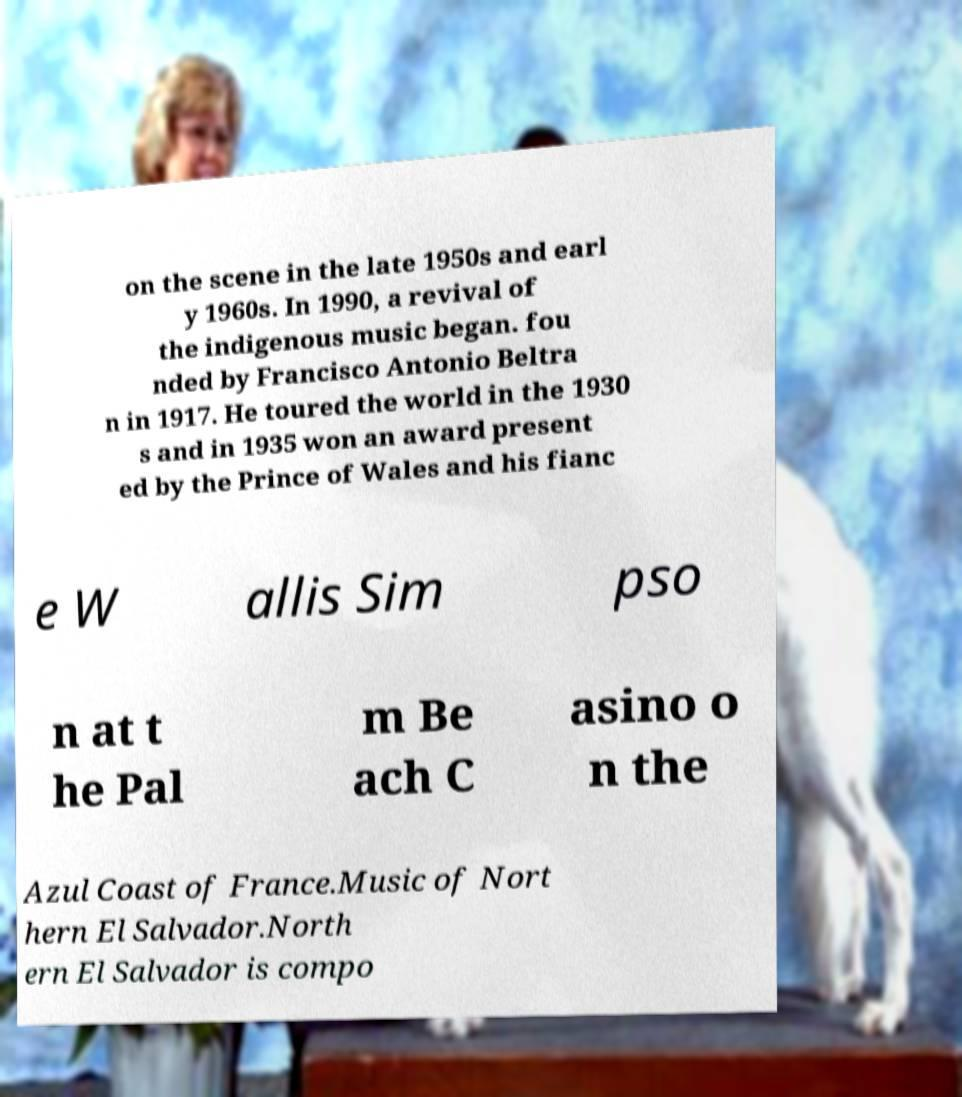For documentation purposes, I need the text within this image transcribed. Could you provide that? on the scene in the late 1950s and earl y 1960s. In 1990, a revival of the indigenous music began. fou nded by Francisco Antonio Beltra n in 1917. He toured the world in the 1930 s and in 1935 won an award present ed by the Prince of Wales and his fianc e W allis Sim pso n at t he Pal m Be ach C asino o n the Azul Coast of France.Music of Nort hern El Salvador.North ern El Salvador is compo 